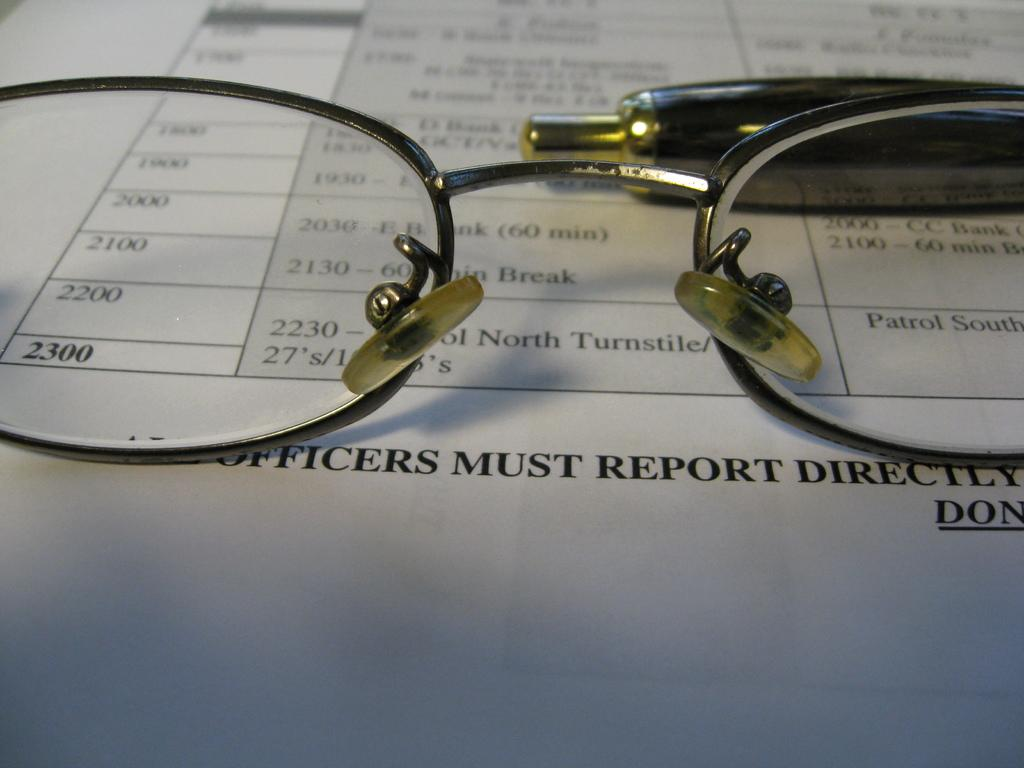What objects are in the foreground of the image? There are spectacles and a pen-like object in the foreground of the image. What can be seen in the background of the image? There is a paper with text and numbers in the background of the image. What type of quilt is being used to cover the paper in the image? There is no quilt present in the image; the paper is not covered by any fabric. 